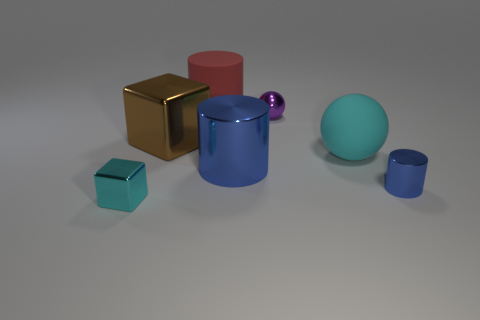How many other objects are there of the same color as the large rubber cylinder?
Your answer should be compact. 0. There is a small block; is its color the same as the large rubber thing on the left side of the big cyan matte object?
Your answer should be very brief. No. How many brown objects are small shiny blocks or big things?
Your answer should be compact. 1. Are there the same number of tiny blocks that are to the right of the big cyan object and big gray metallic cubes?
Ensure brevity in your answer.  Yes. Is there any other thing that has the same size as the cyan rubber object?
Offer a very short reply. Yes. What color is the small shiny thing that is the same shape as the big blue object?
Keep it short and to the point. Blue. What number of other objects have the same shape as the cyan shiny object?
Your answer should be very brief. 1. There is a big thing that is the same color as the small cube; what material is it?
Ensure brevity in your answer.  Rubber. What number of things are there?
Offer a terse response. 7. Are there any tiny things made of the same material as the tiny cyan block?
Offer a terse response. Yes. 